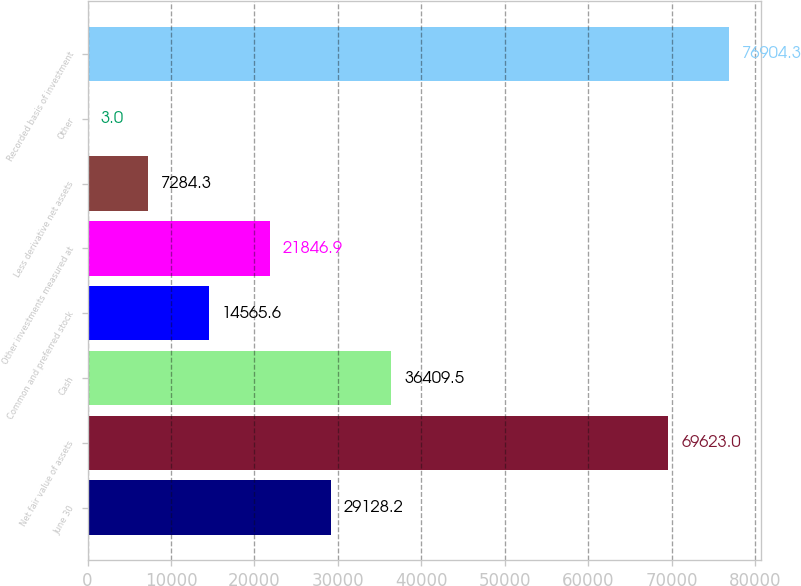<chart> <loc_0><loc_0><loc_500><loc_500><bar_chart><fcel>June 30<fcel>Net fair value of assets<fcel>Cash<fcel>Common and preferred stock<fcel>Other investments measured at<fcel>Less derivative net assets<fcel>Other<fcel>Recorded basis of investment<nl><fcel>29128.2<fcel>69623<fcel>36409.5<fcel>14565.6<fcel>21846.9<fcel>7284.3<fcel>3<fcel>76904.3<nl></chart> 